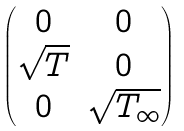Convert formula to latex. <formula><loc_0><loc_0><loc_500><loc_500>\begin{pmatrix} 0 & 0 \\ \sqrt { T } & 0 \\ 0 & \sqrt { T _ { \infty } } \end{pmatrix}</formula> 